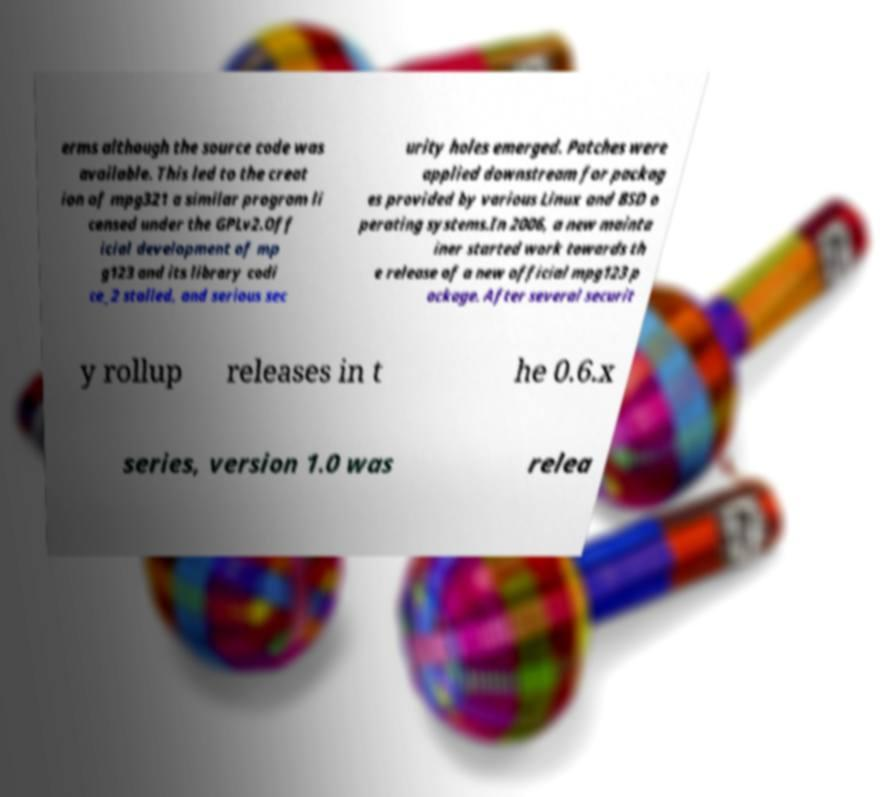Could you extract and type out the text from this image? erms although the source code was available. This led to the creat ion of mpg321 a similar program li censed under the GPLv2.Off icial development of mp g123 and its library codi ce_2 stalled, and serious sec urity holes emerged. Patches were applied downstream for packag es provided by various Linux and BSD o perating systems.In 2006, a new mainta iner started work towards th e release of a new official mpg123 p ackage. After several securit y rollup releases in t he 0.6.x series, version 1.0 was relea 